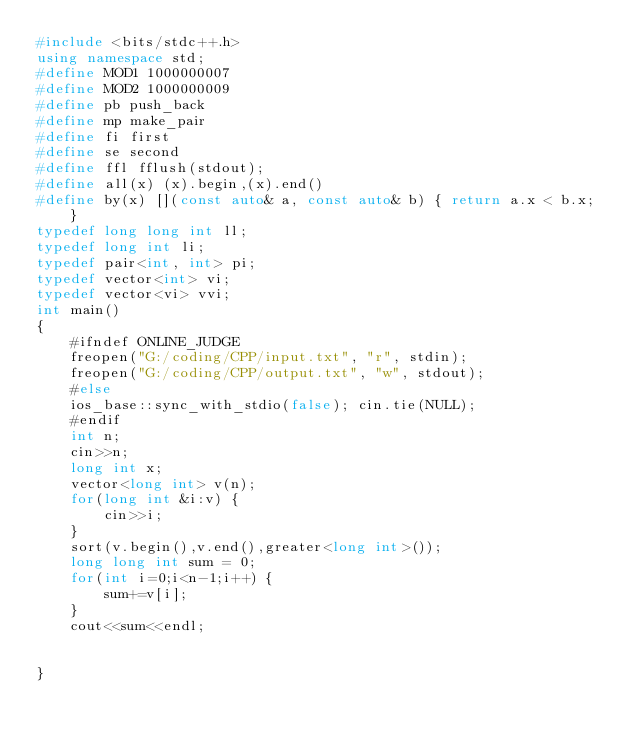Convert code to text. <code><loc_0><loc_0><loc_500><loc_500><_C++_>#include <bits/stdc++.h>
using namespace std;
#define MOD1 1000000007
#define MOD2 1000000009
#define pb push_back
#define mp make_pair
#define fi first
#define se second
#define ffl fflush(stdout);
#define all(x) (x).begin,(x).end()
#define by(x) [](const auto& a, const auto& b) { return a.x < b.x; }
typedef long long int ll;
typedef long int li;
typedef pair<int, int> pi;
typedef vector<int> vi;
typedef vector<vi> vvi;
int main() 
{
	#ifndef ONLINE_JUDGE
	freopen("G:/coding/CPP/input.txt", "r", stdin);
	freopen("G:/coding/CPP/output.txt", "w", stdout);
	#else
	ios_base::sync_with_stdio(false); cin.tie(NULL);
	#endif
	int n;
	cin>>n;
	long int x;
	vector<long int> v(n);
	for(long int &i:v) {
		cin>>i;
	}
	sort(v.begin(),v.end(),greater<long int>());
	long long int sum = 0;
	for(int i=0;i<n-1;i++) {
		sum+=v[i];
	}
	cout<<sum<<endl;
	

}
</code> 